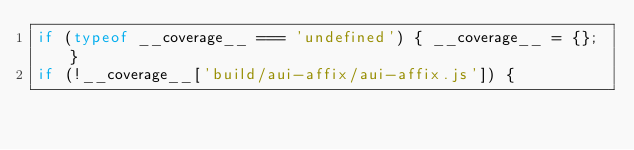<code> <loc_0><loc_0><loc_500><loc_500><_JavaScript_>if (typeof __coverage__ === 'undefined') { __coverage__ = {}; }
if (!__coverage__['build/aui-affix/aui-affix.js']) {</code> 